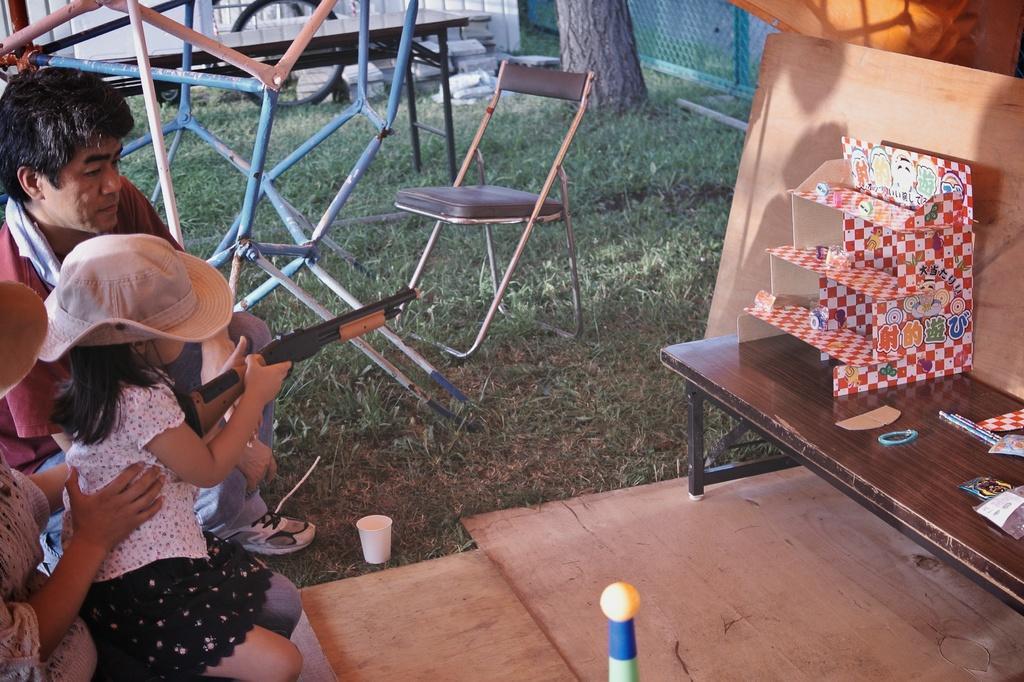How would you summarize this image in a sentence or two? In this picture a girl is aiming the object placed on top of a table. In the background we observe an unoccupied chair and a tree. 